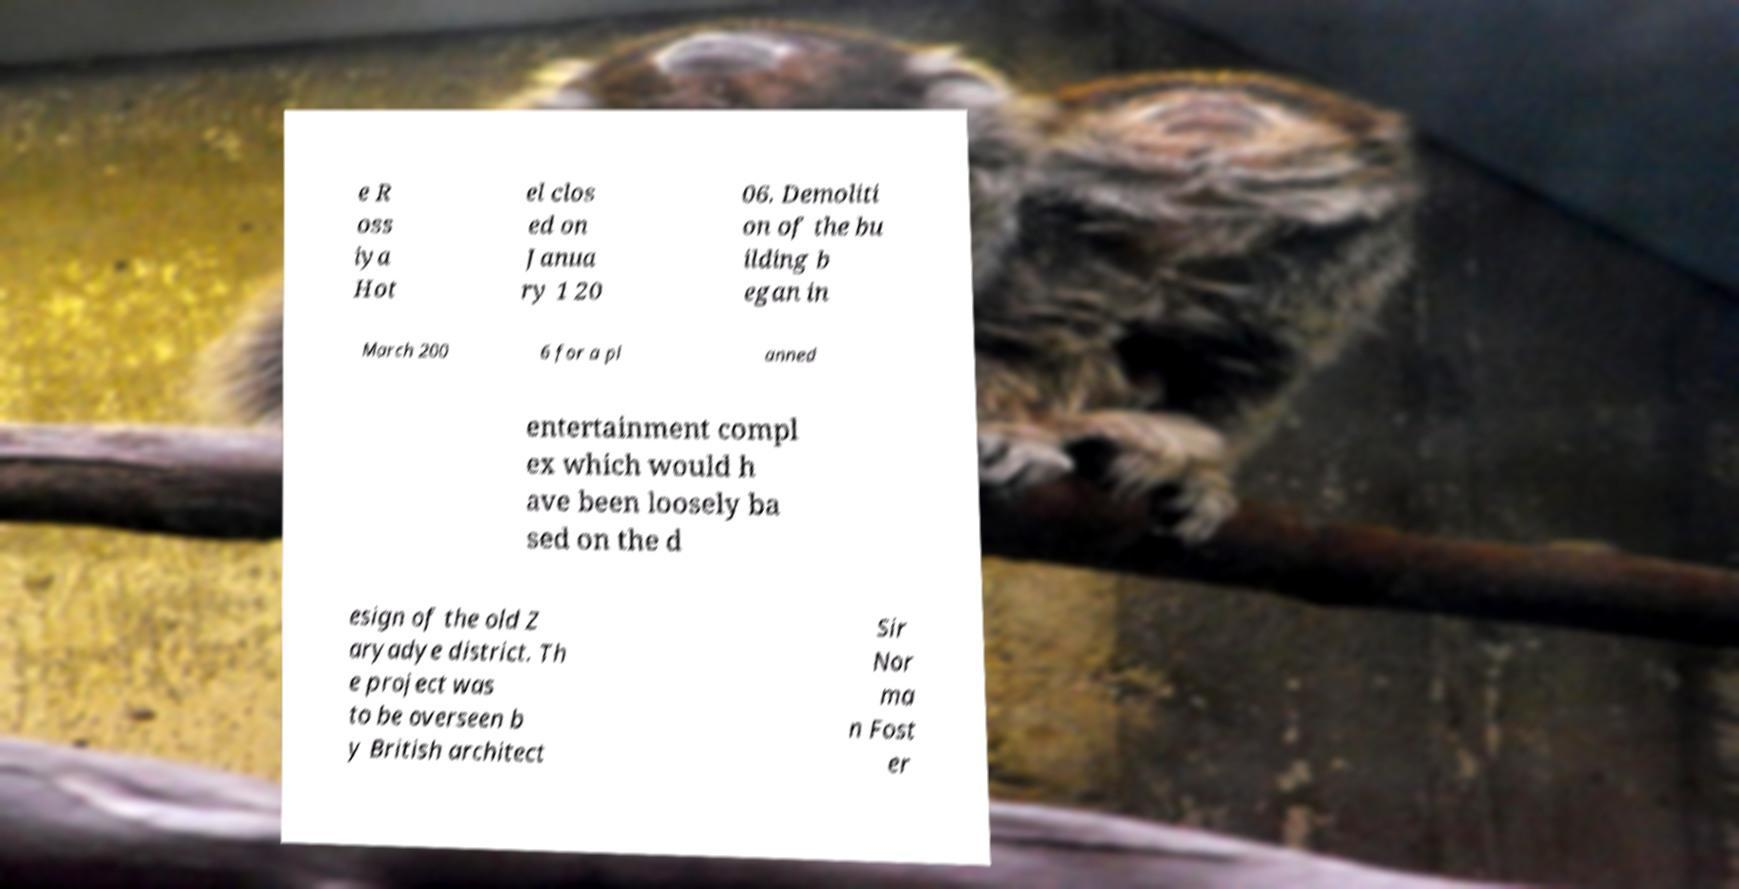What messages or text are displayed in this image? I need them in a readable, typed format. e R oss iya Hot el clos ed on Janua ry 1 20 06. Demoliti on of the bu ilding b egan in March 200 6 for a pl anned entertainment compl ex which would h ave been loosely ba sed on the d esign of the old Z aryadye district. Th e project was to be overseen b y British architect Sir Nor ma n Fost er 